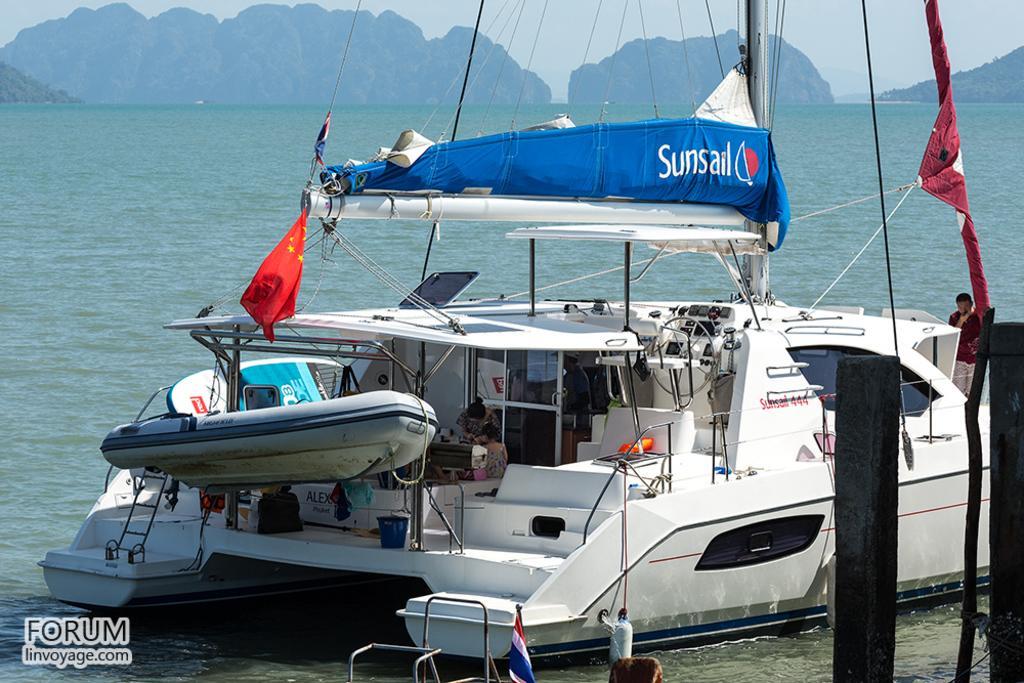In one or two sentences, can you explain what this image depicts? In this image I can see water and in it I can see a white colour boat. I can also see few flags, few ropes, a pole and here I can see one more boat. I can also see something is written on this blue colour thing. Here I can see watermark and I can also see a person is standing on boat. 